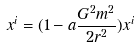Convert formula to latex. <formula><loc_0><loc_0><loc_500><loc_500>x ^ { i } = ( 1 - a \frac { G ^ { 2 } m ^ { 2 } } { 2 r ^ { 2 } } ) x ^ { i }</formula> 